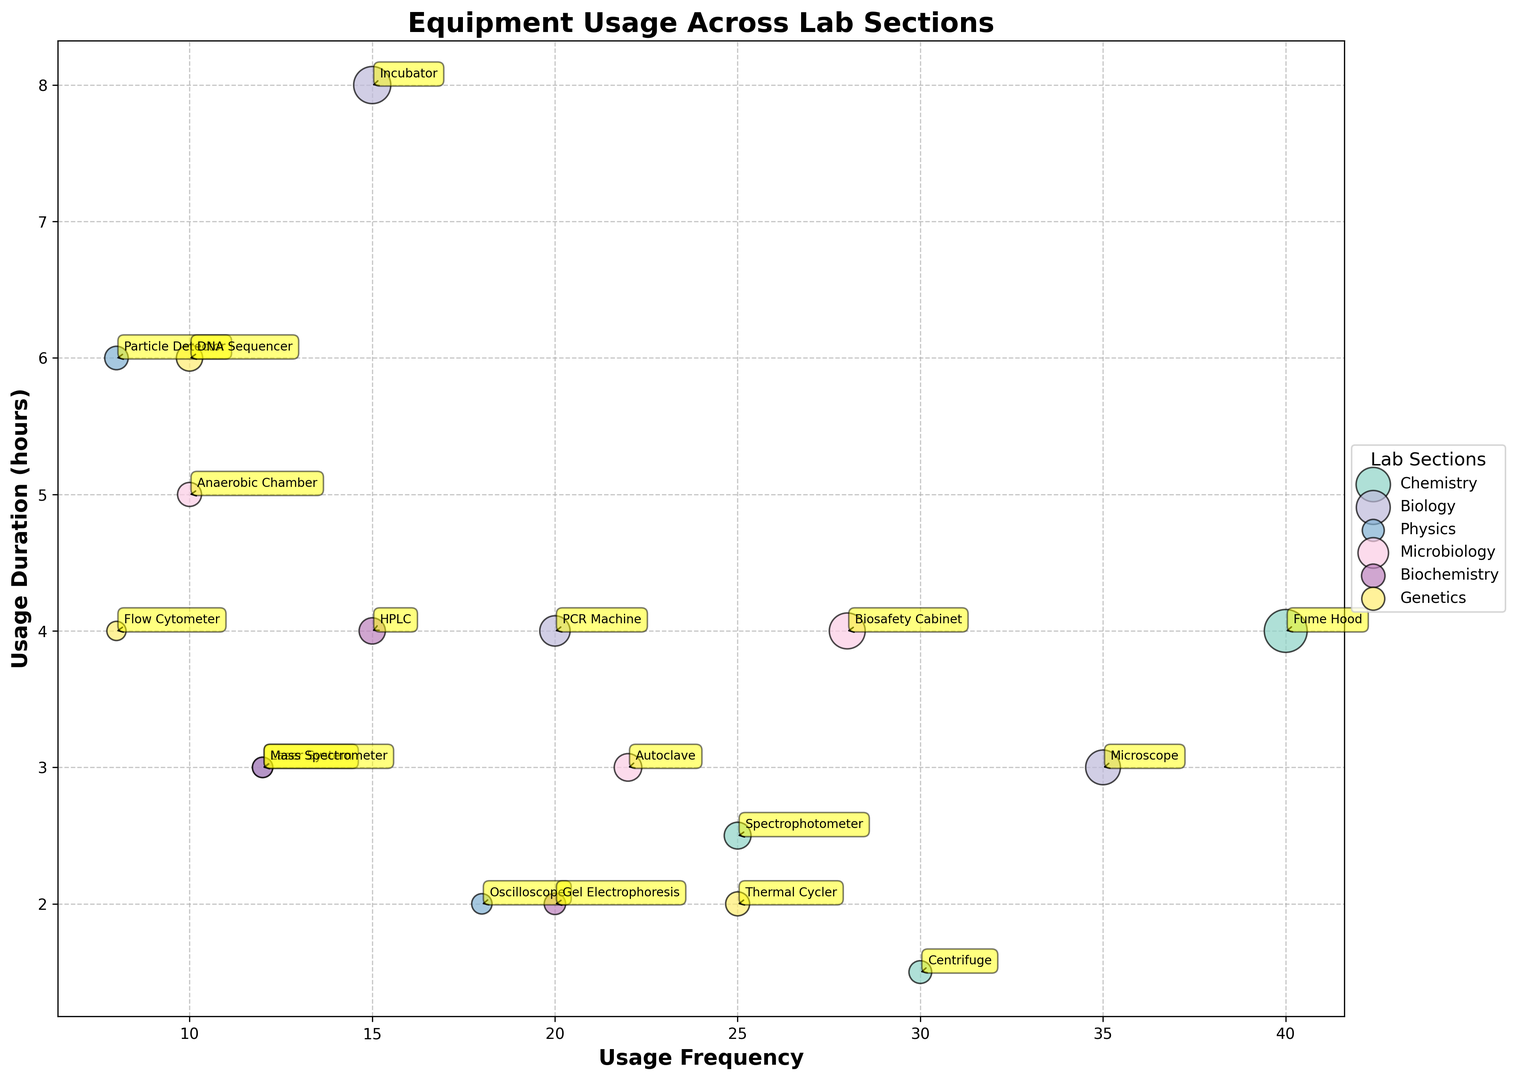Which lab section uses the Fume Hood most frequently? The size of the bubble and the position on the x-axis indicate the usage frequency. The Fume Hood is within the Chemistry section.
Answer: Chemistry Which equipment in the Biology section has the longest usage duration? For the Biology section, locate the equipment with the highest position on the y-axis. The Incubator in the Biology section is at the topmost position in terms of duration.
Answer: Incubator What is the sum of the total usage hours for the Spectrophotometer and the Fume Hood in the Chemistry section? Sum up the total usage hours for the Spectrophotometer and Fume Hood: 62.5 + 160 = 222.5
Answer: 222.5 Which lab section has equipment with both the highest and the lowest usage frequencies? Identify the lab sections with the highest and lowest x-axis positions. Highest is Chemistry (Fume Hood, 40) and lowest is Genetics (Flow Cytometer, 8).
Answer: Chemistry and Genetics How does the usage duration of the Autoclave compare to the Anaerobic Chamber in the Microbiology section? Compare the y-axis positions within the Microbiology section. The Autoclave has a duration of 3 hours, while the Anaerobic Chamber has 5 hours.
Answer: Autoclave < Anaerobic Chamber Which lab section uses the Oscilloscope, and what are its usage frequency and duration? Find the Oscilloscope label and check its x and y-axis positions, also noting its lab section. The Oscilloscope is in the Physics section with a usage frequency of 18 and a duration of 2 hours.
Answer: Physics, 18, 2 What is the average usage duration of equipment in the Genetics section? Sum the usage durations: 6 (DNA Sequencer) + 4 (Flow Cytometer) + 2 (Thermal Cycler) = 12, then divide by the number of equipment: 12 / 3 = 4
Answer: 4 Which piece of equipment in the Biochemistry section has the smallest total usage hours? Compare the bubble sizes in the Biochemistry section. The Mass Spectrometer has the smallest bubble.
Answer: Mass Spectrometer 